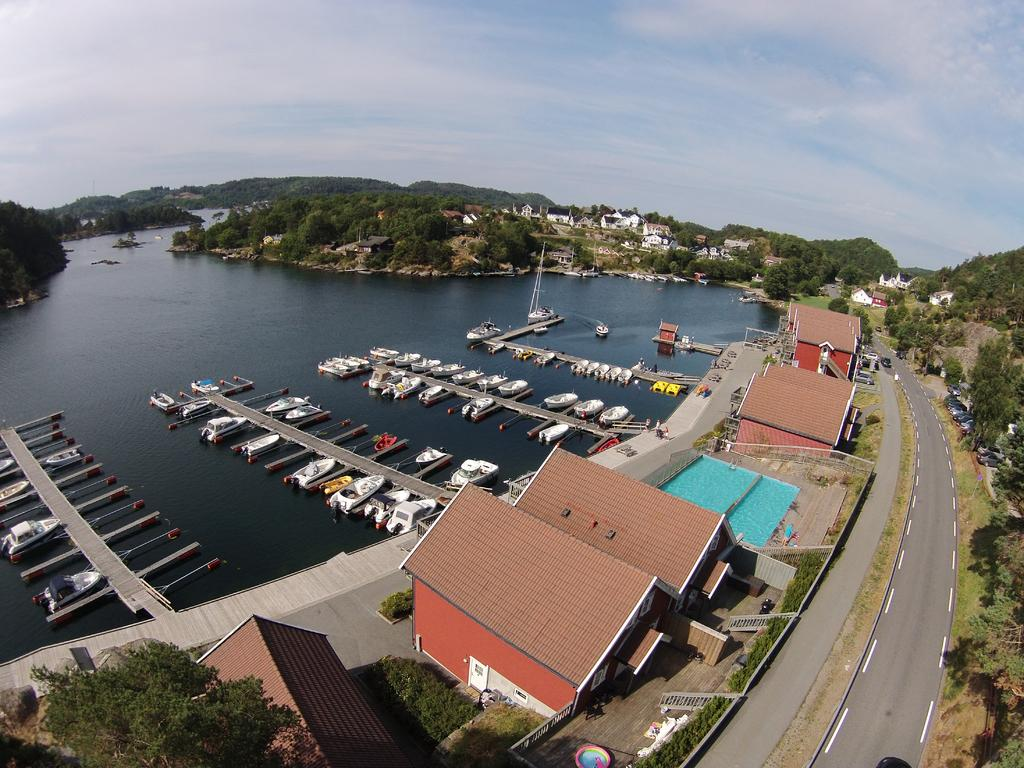What natural element can be seen in the image? Water is visible in the image. What type of vegetation is present in the image? There are trees and grass visible in the image. What type of structures can be seen in the image? There are houses in the image. What mode of transportation is present in the image? There are boats in the image. What is visible at the top of the image? The sky is visible at the top of the image. Can you tell me how many birds are laughing in the image? There are no birds present in the image, and therefore no such activity can be observed. 